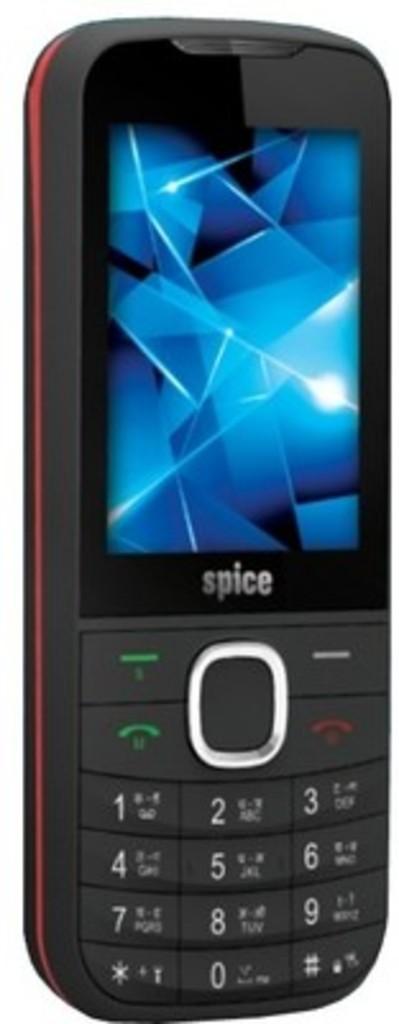What brand of cellphone is this?
Ensure brevity in your answer.  Spice. Does this phone have a 0 button?
Your response must be concise. Yes. 